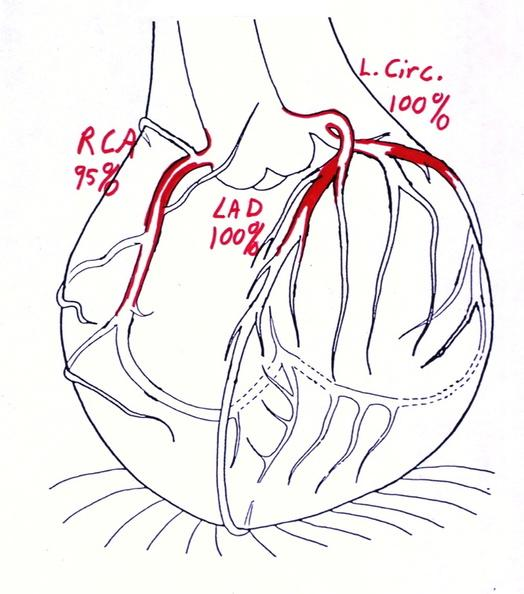does atrophy show coronary artery atherosclerosis diagram?
Answer the question using a single word or phrase. No 